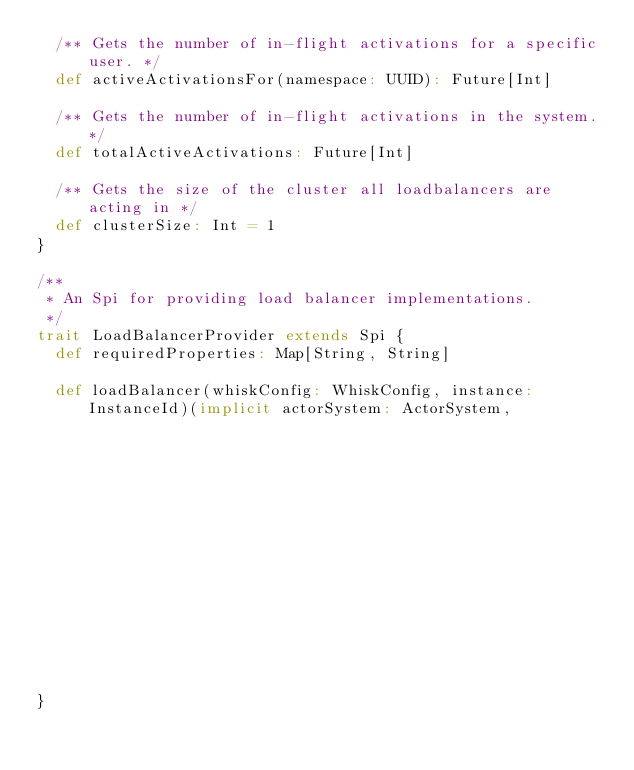<code> <loc_0><loc_0><loc_500><loc_500><_Scala_>  /** Gets the number of in-flight activations for a specific user. */
  def activeActivationsFor(namespace: UUID): Future[Int]

  /** Gets the number of in-flight activations in the system. */
  def totalActiveActivations: Future[Int]

  /** Gets the size of the cluster all loadbalancers are acting in */
  def clusterSize: Int = 1
}

/**
 * An Spi for providing load balancer implementations.
 */
trait LoadBalancerProvider extends Spi {
  def requiredProperties: Map[String, String]

  def loadBalancer(whiskConfig: WhiskConfig, instance: InstanceId)(implicit actorSystem: ActorSystem,
                                                                   logging: Logging,
                                                                   materializer: ActorMaterializer): LoadBalancer
}
</code> 